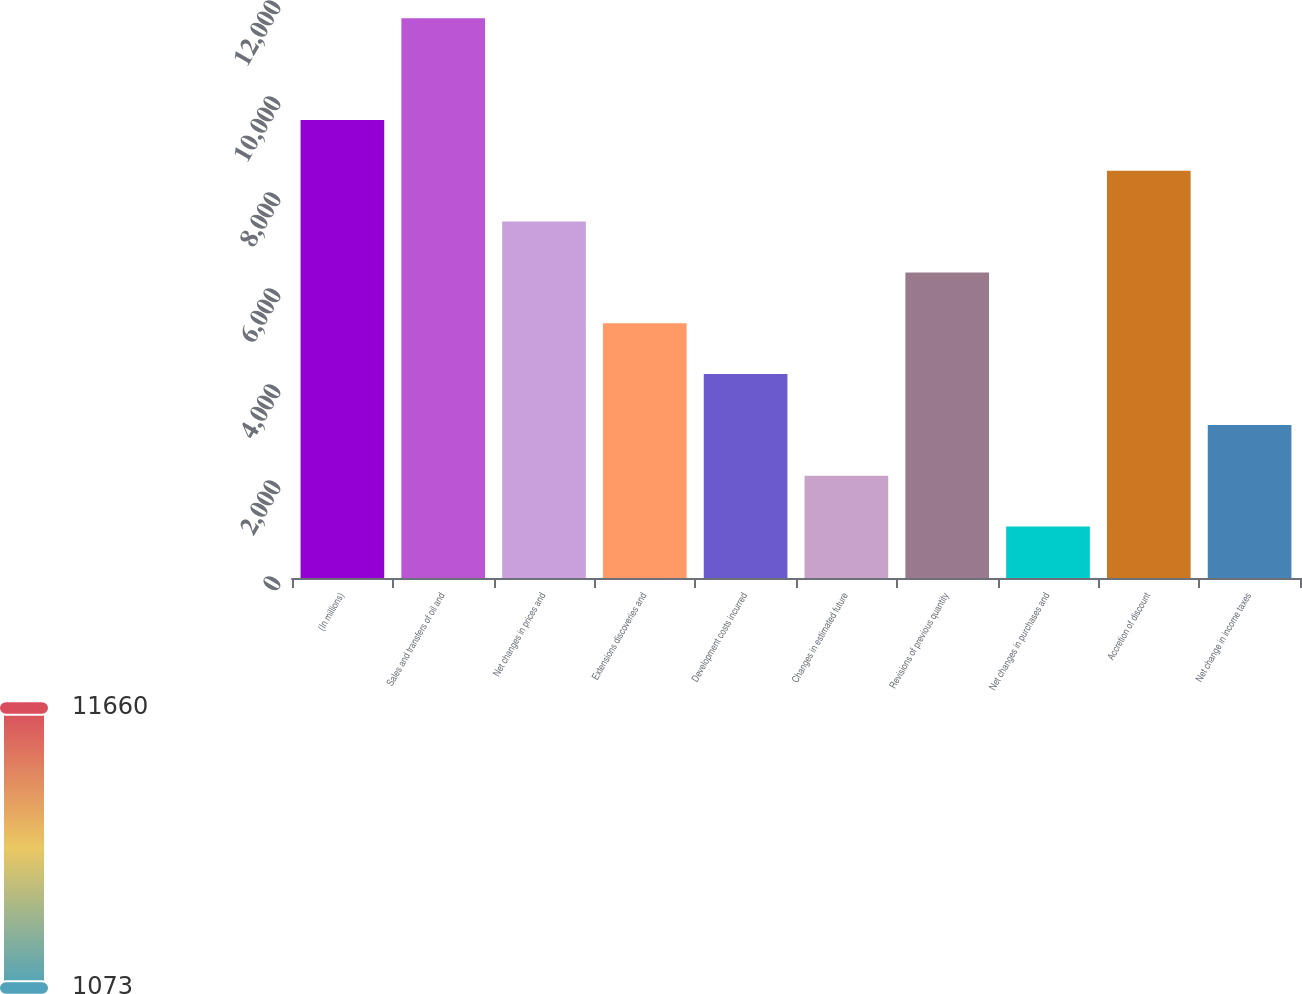<chart> <loc_0><loc_0><loc_500><loc_500><bar_chart><fcel>(In millions)<fcel>Sales and transfers of oil and<fcel>Net changes in prices and<fcel>Extensions discoveries and<fcel>Development costs incurred<fcel>Changes in estimated future<fcel>Revisions of previous quantity<fcel>Net changes in purchases and<fcel>Accretion of discount<fcel>Net change in income taxes<nl><fcel>9542.3<fcel>11659.7<fcel>7424.9<fcel>5307.5<fcel>4248.8<fcel>2131.4<fcel>6366.2<fcel>1072.7<fcel>8483.6<fcel>3190.1<nl></chart> 